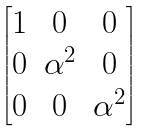Convert formula to latex. <formula><loc_0><loc_0><loc_500><loc_500>\begin{bmatrix} 1 & 0 & 0 \\ 0 & \alpha ^ { 2 } & 0 \\ 0 & 0 & \alpha ^ { 2 } \end{bmatrix}</formula> 